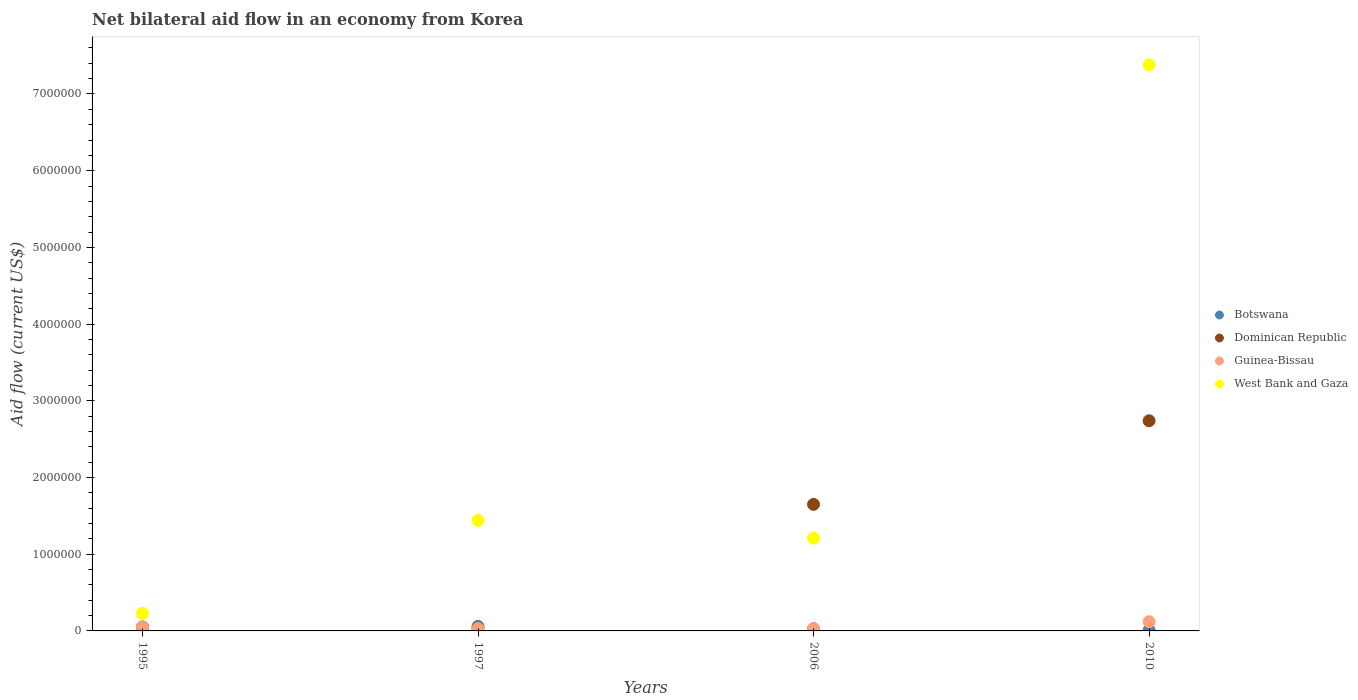How many different coloured dotlines are there?
Your answer should be very brief. 4. Is the number of dotlines equal to the number of legend labels?
Provide a short and direct response. Yes. Across all years, what is the maximum net bilateral aid flow in Dominican Republic?
Provide a short and direct response. 2.74e+06. Across all years, what is the minimum net bilateral aid flow in Botswana?
Provide a short and direct response. 10000. In which year was the net bilateral aid flow in Botswana maximum?
Offer a terse response. 1997. What is the difference between the net bilateral aid flow in Dominican Republic in 1995 and that in 2010?
Your answer should be compact. -2.69e+06. What is the difference between the net bilateral aid flow in Botswana in 1995 and the net bilateral aid flow in Dominican Republic in 2010?
Your answer should be very brief. -2.69e+06. What is the average net bilateral aid flow in Dominican Republic per year?
Keep it short and to the point. 1.12e+06. In the year 1997, what is the difference between the net bilateral aid flow in Guinea-Bissau and net bilateral aid flow in Botswana?
Make the answer very short. -3.00e+04. What is the ratio of the net bilateral aid flow in Dominican Republic in 1995 to that in 2010?
Offer a terse response. 0.02. Is the net bilateral aid flow in Guinea-Bissau in 1995 less than that in 2006?
Give a very brief answer. No. Is the difference between the net bilateral aid flow in Guinea-Bissau in 1995 and 2006 greater than the difference between the net bilateral aid flow in Botswana in 1995 and 2006?
Give a very brief answer. No. What is the difference between the highest and the second highest net bilateral aid flow in Dominican Republic?
Ensure brevity in your answer.  1.09e+06. What is the difference between the highest and the lowest net bilateral aid flow in Guinea-Bissau?
Provide a short and direct response. 9.00e+04. Is it the case that in every year, the sum of the net bilateral aid flow in West Bank and Gaza and net bilateral aid flow in Guinea-Bissau  is greater than the sum of net bilateral aid flow in Dominican Republic and net bilateral aid flow in Botswana?
Provide a short and direct response. Yes. Is it the case that in every year, the sum of the net bilateral aid flow in Dominican Republic and net bilateral aid flow in Botswana  is greater than the net bilateral aid flow in Guinea-Bissau?
Keep it short and to the point. Yes. Does the net bilateral aid flow in West Bank and Gaza monotonically increase over the years?
Your answer should be compact. No. Is the net bilateral aid flow in West Bank and Gaza strictly greater than the net bilateral aid flow in Dominican Republic over the years?
Your response must be concise. No. How many years are there in the graph?
Keep it short and to the point. 4. What is the difference between two consecutive major ticks on the Y-axis?
Your response must be concise. 1.00e+06. Where does the legend appear in the graph?
Your answer should be very brief. Center right. How many legend labels are there?
Keep it short and to the point. 4. What is the title of the graph?
Offer a terse response. Net bilateral aid flow in an economy from Korea. What is the Aid flow (current US$) in Dominican Republic in 1995?
Give a very brief answer. 5.00e+04. What is the Aid flow (current US$) in Guinea-Bissau in 1995?
Keep it short and to the point. 5.00e+04. What is the Aid flow (current US$) in West Bank and Gaza in 1995?
Offer a terse response. 2.30e+05. What is the Aid flow (current US$) in Dominican Republic in 1997?
Provide a short and direct response. 3.00e+04. What is the Aid flow (current US$) in Guinea-Bissau in 1997?
Your answer should be very brief. 3.00e+04. What is the Aid flow (current US$) of West Bank and Gaza in 1997?
Make the answer very short. 1.44e+06. What is the Aid flow (current US$) of Botswana in 2006?
Your response must be concise. 3.00e+04. What is the Aid flow (current US$) of Dominican Republic in 2006?
Keep it short and to the point. 1.65e+06. What is the Aid flow (current US$) in West Bank and Gaza in 2006?
Keep it short and to the point. 1.21e+06. What is the Aid flow (current US$) in Dominican Republic in 2010?
Your response must be concise. 2.74e+06. What is the Aid flow (current US$) of West Bank and Gaza in 2010?
Provide a short and direct response. 7.38e+06. Across all years, what is the maximum Aid flow (current US$) in Dominican Republic?
Ensure brevity in your answer.  2.74e+06. Across all years, what is the maximum Aid flow (current US$) in West Bank and Gaza?
Make the answer very short. 7.38e+06. Across all years, what is the minimum Aid flow (current US$) of Dominican Republic?
Keep it short and to the point. 3.00e+04. Across all years, what is the minimum Aid flow (current US$) of Guinea-Bissau?
Your response must be concise. 3.00e+04. Across all years, what is the minimum Aid flow (current US$) in West Bank and Gaza?
Ensure brevity in your answer.  2.30e+05. What is the total Aid flow (current US$) in Dominican Republic in the graph?
Ensure brevity in your answer.  4.47e+06. What is the total Aid flow (current US$) of West Bank and Gaza in the graph?
Offer a terse response. 1.03e+07. What is the difference between the Aid flow (current US$) in West Bank and Gaza in 1995 and that in 1997?
Provide a succinct answer. -1.21e+06. What is the difference between the Aid flow (current US$) in Dominican Republic in 1995 and that in 2006?
Your response must be concise. -1.60e+06. What is the difference between the Aid flow (current US$) in West Bank and Gaza in 1995 and that in 2006?
Your answer should be very brief. -9.80e+05. What is the difference between the Aid flow (current US$) of Dominican Republic in 1995 and that in 2010?
Ensure brevity in your answer.  -2.69e+06. What is the difference between the Aid flow (current US$) in West Bank and Gaza in 1995 and that in 2010?
Your response must be concise. -7.15e+06. What is the difference between the Aid flow (current US$) in Botswana in 1997 and that in 2006?
Make the answer very short. 3.00e+04. What is the difference between the Aid flow (current US$) of Dominican Republic in 1997 and that in 2006?
Keep it short and to the point. -1.62e+06. What is the difference between the Aid flow (current US$) in Botswana in 1997 and that in 2010?
Your response must be concise. 5.00e+04. What is the difference between the Aid flow (current US$) in Dominican Republic in 1997 and that in 2010?
Give a very brief answer. -2.71e+06. What is the difference between the Aid flow (current US$) of West Bank and Gaza in 1997 and that in 2010?
Your response must be concise. -5.94e+06. What is the difference between the Aid flow (current US$) of Dominican Republic in 2006 and that in 2010?
Provide a short and direct response. -1.09e+06. What is the difference between the Aid flow (current US$) of West Bank and Gaza in 2006 and that in 2010?
Provide a short and direct response. -6.17e+06. What is the difference between the Aid flow (current US$) in Botswana in 1995 and the Aid flow (current US$) in Guinea-Bissau in 1997?
Your answer should be compact. 2.00e+04. What is the difference between the Aid flow (current US$) in Botswana in 1995 and the Aid flow (current US$) in West Bank and Gaza in 1997?
Give a very brief answer. -1.39e+06. What is the difference between the Aid flow (current US$) of Dominican Republic in 1995 and the Aid flow (current US$) of West Bank and Gaza in 1997?
Your response must be concise. -1.39e+06. What is the difference between the Aid flow (current US$) of Guinea-Bissau in 1995 and the Aid flow (current US$) of West Bank and Gaza in 1997?
Give a very brief answer. -1.39e+06. What is the difference between the Aid flow (current US$) of Botswana in 1995 and the Aid flow (current US$) of Dominican Republic in 2006?
Ensure brevity in your answer.  -1.60e+06. What is the difference between the Aid flow (current US$) in Botswana in 1995 and the Aid flow (current US$) in West Bank and Gaza in 2006?
Make the answer very short. -1.16e+06. What is the difference between the Aid flow (current US$) of Dominican Republic in 1995 and the Aid flow (current US$) of West Bank and Gaza in 2006?
Offer a very short reply. -1.16e+06. What is the difference between the Aid flow (current US$) of Guinea-Bissau in 1995 and the Aid flow (current US$) of West Bank and Gaza in 2006?
Keep it short and to the point. -1.16e+06. What is the difference between the Aid flow (current US$) of Botswana in 1995 and the Aid flow (current US$) of Dominican Republic in 2010?
Offer a terse response. -2.69e+06. What is the difference between the Aid flow (current US$) in Botswana in 1995 and the Aid flow (current US$) in Guinea-Bissau in 2010?
Offer a terse response. -7.00e+04. What is the difference between the Aid flow (current US$) in Botswana in 1995 and the Aid flow (current US$) in West Bank and Gaza in 2010?
Give a very brief answer. -7.33e+06. What is the difference between the Aid flow (current US$) in Dominican Republic in 1995 and the Aid flow (current US$) in West Bank and Gaza in 2010?
Give a very brief answer. -7.33e+06. What is the difference between the Aid flow (current US$) of Guinea-Bissau in 1995 and the Aid flow (current US$) of West Bank and Gaza in 2010?
Keep it short and to the point. -7.33e+06. What is the difference between the Aid flow (current US$) of Botswana in 1997 and the Aid flow (current US$) of Dominican Republic in 2006?
Offer a very short reply. -1.59e+06. What is the difference between the Aid flow (current US$) of Botswana in 1997 and the Aid flow (current US$) of Guinea-Bissau in 2006?
Give a very brief answer. 3.00e+04. What is the difference between the Aid flow (current US$) of Botswana in 1997 and the Aid flow (current US$) of West Bank and Gaza in 2006?
Offer a very short reply. -1.15e+06. What is the difference between the Aid flow (current US$) in Dominican Republic in 1997 and the Aid flow (current US$) in Guinea-Bissau in 2006?
Ensure brevity in your answer.  0. What is the difference between the Aid flow (current US$) in Dominican Republic in 1997 and the Aid flow (current US$) in West Bank and Gaza in 2006?
Offer a very short reply. -1.18e+06. What is the difference between the Aid flow (current US$) in Guinea-Bissau in 1997 and the Aid flow (current US$) in West Bank and Gaza in 2006?
Ensure brevity in your answer.  -1.18e+06. What is the difference between the Aid flow (current US$) of Botswana in 1997 and the Aid flow (current US$) of Dominican Republic in 2010?
Your answer should be very brief. -2.68e+06. What is the difference between the Aid flow (current US$) in Botswana in 1997 and the Aid flow (current US$) in West Bank and Gaza in 2010?
Provide a short and direct response. -7.32e+06. What is the difference between the Aid flow (current US$) of Dominican Republic in 1997 and the Aid flow (current US$) of West Bank and Gaza in 2010?
Provide a short and direct response. -7.35e+06. What is the difference between the Aid flow (current US$) of Guinea-Bissau in 1997 and the Aid flow (current US$) of West Bank and Gaza in 2010?
Keep it short and to the point. -7.35e+06. What is the difference between the Aid flow (current US$) of Botswana in 2006 and the Aid flow (current US$) of Dominican Republic in 2010?
Provide a succinct answer. -2.71e+06. What is the difference between the Aid flow (current US$) of Botswana in 2006 and the Aid flow (current US$) of West Bank and Gaza in 2010?
Your answer should be compact. -7.35e+06. What is the difference between the Aid flow (current US$) of Dominican Republic in 2006 and the Aid flow (current US$) of Guinea-Bissau in 2010?
Make the answer very short. 1.53e+06. What is the difference between the Aid flow (current US$) of Dominican Republic in 2006 and the Aid flow (current US$) of West Bank and Gaza in 2010?
Offer a terse response. -5.73e+06. What is the difference between the Aid flow (current US$) of Guinea-Bissau in 2006 and the Aid flow (current US$) of West Bank and Gaza in 2010?
Offer a terse response. -7.35e+06. What is the average Aid flow (current US$) in Botswana per year?
Offer a terse response. 3.75e+04. What is the average Aid flow (current US$) of Dominican Republic per year?
Your answer should be very brief. 1.12e+06. What is the average Aid flow (current US$) in Guinea-Bissau per year?
Provide a succinct answer. 5.75e+04. What is the average Aid flow (current US$) in West Bank and Gaza per year?
Your answer should be compact. 2.56e+06. In the year 1995, what is the difference between the Aid flow (current US$) of Botswana and Aid flow (current US$) of Guinea-Bissau?
Give a very brief answer. 0. In the year 1995, what is the difference between the Aid flow (current US$) of Botswana and Aid flow (current US$) of West Bank and Gaza?
Your response must be concise. -1.80e+05. In the year 1997, what is the difference between the Aid flow (current US$) of Botswana and Aid flow (current US$) of Dominican Republic?
Give a very brief answer. 3.00e+04. In the year 1997, what is the difference between the Aid flow (current US$) of Botswana and Aid flow (current US$) of West Bank and Gaza?
Your answer should be compact. -1.38e+06. In the year 1997, what is the difference between the Aid flow (current US$) of Dominican Republic and Aid flow (current US$) of Guinea-Bissau?
Keep it short and to the point. 0. In the year 1997, what is the difference between the Aid flow (current US$) of Dominican Republic and Aid flow (current US$) of West Bank and Gaza?
Provide a succinct answer. -1.41e+06. In the year 1997, what is the difference between the Aid flow (current US$) in Guinea-Bissau and Aid flow (current US$) in West Bank and Gaza?
Your answer should be compact. -1.41e+06. In the year 2006, what is the difference between the Aid flow (current US$) of Botswana and Aid flow (current US$) of Dominican Republic?
Provide a short and direct response. -1.62e+06. In the year 2006, what is the difference between the Aid flow (current US$) of Botswana and Aid flow (current US$) of Guinea-Bissau?
Your answer should be compact. 0. In the year 2006, what is the difference between the Aid flow (current US$) in Botswana and Aid flow (current US$) in West Bank and Gaza?
Your response must be concise. -1.18e+06. In the year 2006, what is the difference between the Aid flow (current US$) of Dominican Republic and Aid flow (current US$) of Guinea-Bissau?
Make the answer very short. 1.62e+06. In the year 2006, what is the difference between the Aid flow (current US$) in Guinea-Bissau and Aid flow (current US$) in West Bank and Gaza?
Offer a very short reply. -1.18e+06. In the year 2010, what is the difference between the Aid flow (current US$) in Botswana and Aid flow (current US$) in Dominican Republic?
Your response must be concise. -2.73e+06. In the year 2010, what is the difference between the Aid flow (current US$) in Botswana and Aid flow (current US$) in Guinea-Bissau?
Provide a succinct answer. -1.10e+05. In the year 2010, what is the difference between the Aid flow (current US$) of Botswana and Aid flow (current US$) of West Bank and Gaza?
Your answer should be very brief. -7.37e+06. In the year 2010, what is the difference between the Aid flow (current US$) of Dominican Republic and Aid flow (current US$) of Guinea-Bissau?
Give a very brief answer. 2.62e+06. In the year 2010, what is the difference between the Aid flow (current US$) of Dominican Republic and Aid flow (current US$) of West Bank and Gaza?
Make the answer very short. -4.64e+06. In the year 2010, what is the difference between the Aid flow (current US$) in Guinea-Bissau and Aid flow (current US$) in West Bank and Gaza?
Keep it short and to the point. -7.26e+06. What is the ratio of the Aid flow (current US$) in Dominican Republic in 1995 to that in 1997?
Provide a succinct answer. 1.67. What is the ratio of the Aid flow (current US$) in West Bank and Gaza in 1995 to that in 1997?
Offer a very short reply. 0.16. What is the ratio of the Aid flow (current US$) of Dominican Republic in 1995 to that in 2006?
Provide a succinct answer. 0.03. What is the ratio of the Aid flow (current US$) in Guinea-Bissau in 1995 to that in 2006?
Ensure brevity in your answer.  1.67. What is the ratio of the Aid flow (current US$) in West Bank and Gaza in 1995 to that in 2006?
Give a very brief answer. 0.19. What is the ratio of the Aid flow (current US$) of Dominican Republic in 1995 to that in 2010?
Your answer should be very brief. 0.02. What is the ratio of the Aid flow (current US$) in Guinea-Bissau in 1995 to that in 2010?
Make the answer very short. 0.42. What is the ratio of the Aid flow (current US$) of West Bank and Gaza in 1995 to that in 2010?
Make the answer very short. 0.03. What is the ratio of the Aid flow (current US$) of Dominican Republic in 1997 to that in 2006?
Your answer should be compact. 0.02. What is the ratio of the Aid flow (current US$) of West Bank and Gaza in 1997 to that in 2006?
Ensure brevity in your answer.  1.19. What is the ratio of the Aid flow (current US$) in Dominican Republic in 1997 to that in 2010?
Ensure brevity in your answer.  0.01. What is the ratio of the Aid flow (current US$) in West Bank and Gaza in 1997 to that in 2010?
Your answer should be very brief. 0.2. What is the ratio of the Aid flow (current US$) in Dominican Republic in 2006 to that in 2010?
Provide a short and direct response. 0.6. What is the ratio of the Aid flow (current US$) of Guinea-Bissau in 2006 to that in 2010?
Offer a terse response. 0.25. What is the ratio of the Aid flow (current US$) in West Bank and Gaza in 2006 to that in 2010?
Provide a short and direct response. 0.16. What is the difference between the highest and the second highest Aid flow (current US$) in Dominican Republic?
Your response must be concise. 1.09e+06. What is the difference between the highest and the second highest Aid flow (current US$) in West Bank and Gaza?
Keep it short and to the point. 5.94e+06. What is the difference between the highest and the lowest Aid flow (current US$) in Dominican Republic?
Make the answer very short. 2.71e+06. What is the difference between the highest and the lowest Aid flow (current US$) in Guinea-Bissau?
Provide a short and direct response. 9.00e+04. What is the difference between the highest and the lowest Aid flow (current US$) in West Bank and Gaza?
Your answer should be compact. 7.15e+06. 